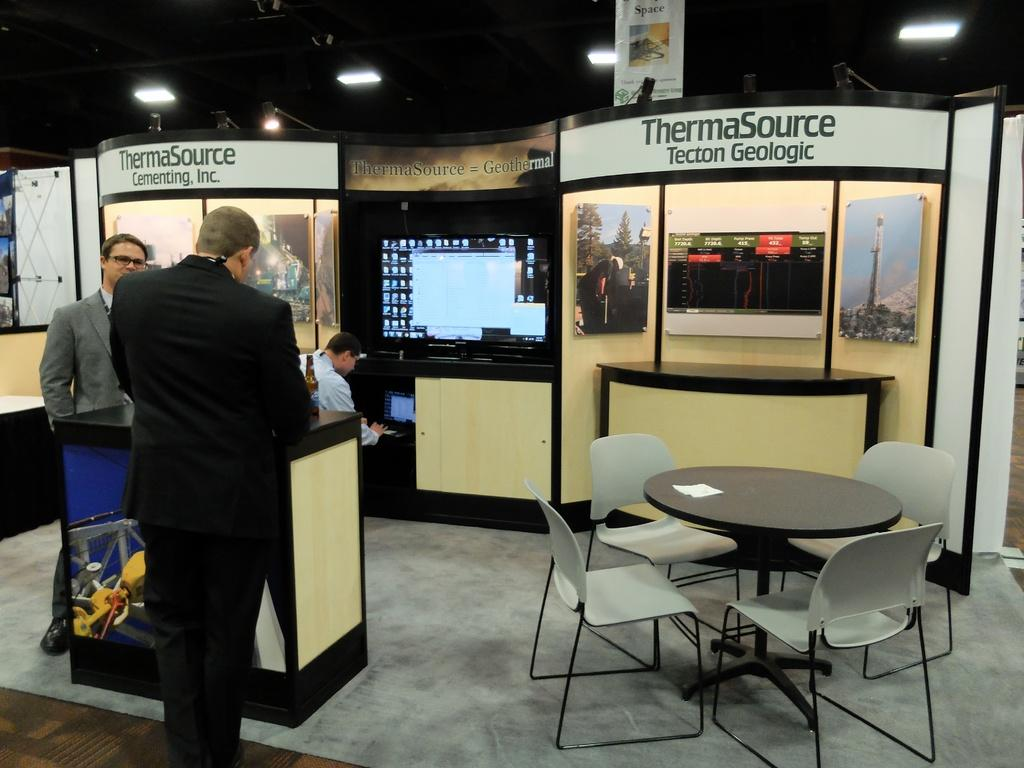How many people are standing in the image? There are two persons standing in the image. What is the position of the third person in the image? There is a person sitting in the image. What electronic device can be seen in the image? There is a television in the image. What type of decorations are present in the image? There are posters in the image. What type of furniture is visible in the image? There is a table and chairs in the image. What part of the room is visible in the image? The floor is visible in the image. What type of lighting is present in the image? There are lights visible in the image. What additional signage is present in the image? There is a banner in the image. Are there any cobwebs visible in the image? There is no mention of cobwebs in the provided facts, and therefore we cannot determine their presence in the image. What is the name of the person sitting in the image? The provided facts do not mention any names, so we cannot determine the name of the person sitting in the image. 